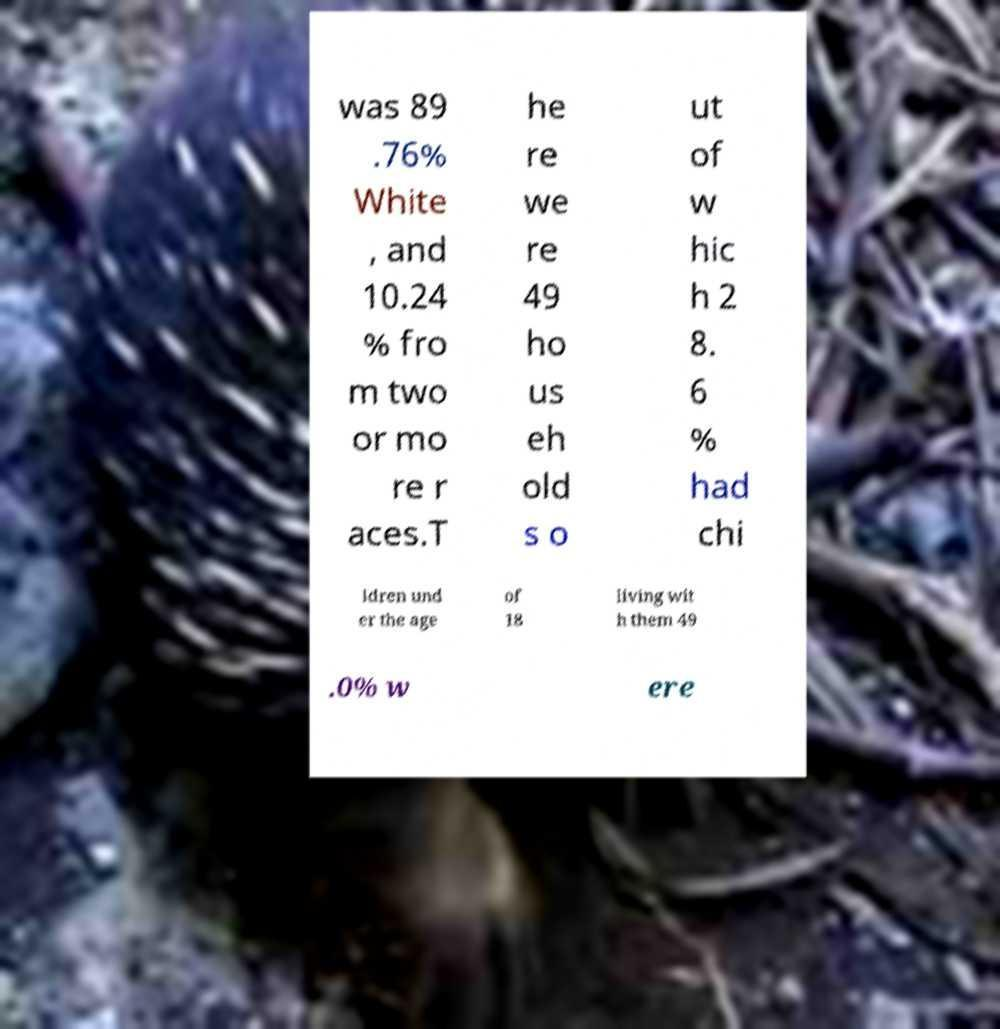Please identify and transcribe the text found in this image. was 89 .76% White , and 10.24 % fro m two or mo re r aces.T he re we re 49 ho us eh old s o ut of w hic h 2 8. 6 % had chi ldren und er the age of 18 living wit h them 49 .0% w ere 